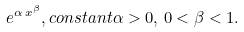<formula> <loc_0><loc_0><loc_500><loc_500>e ^ { \alpha \, x ^ { \beta } } , c o n s t a n t \alpha > 0 , \, 0 < \beta < 1 .</formula> 